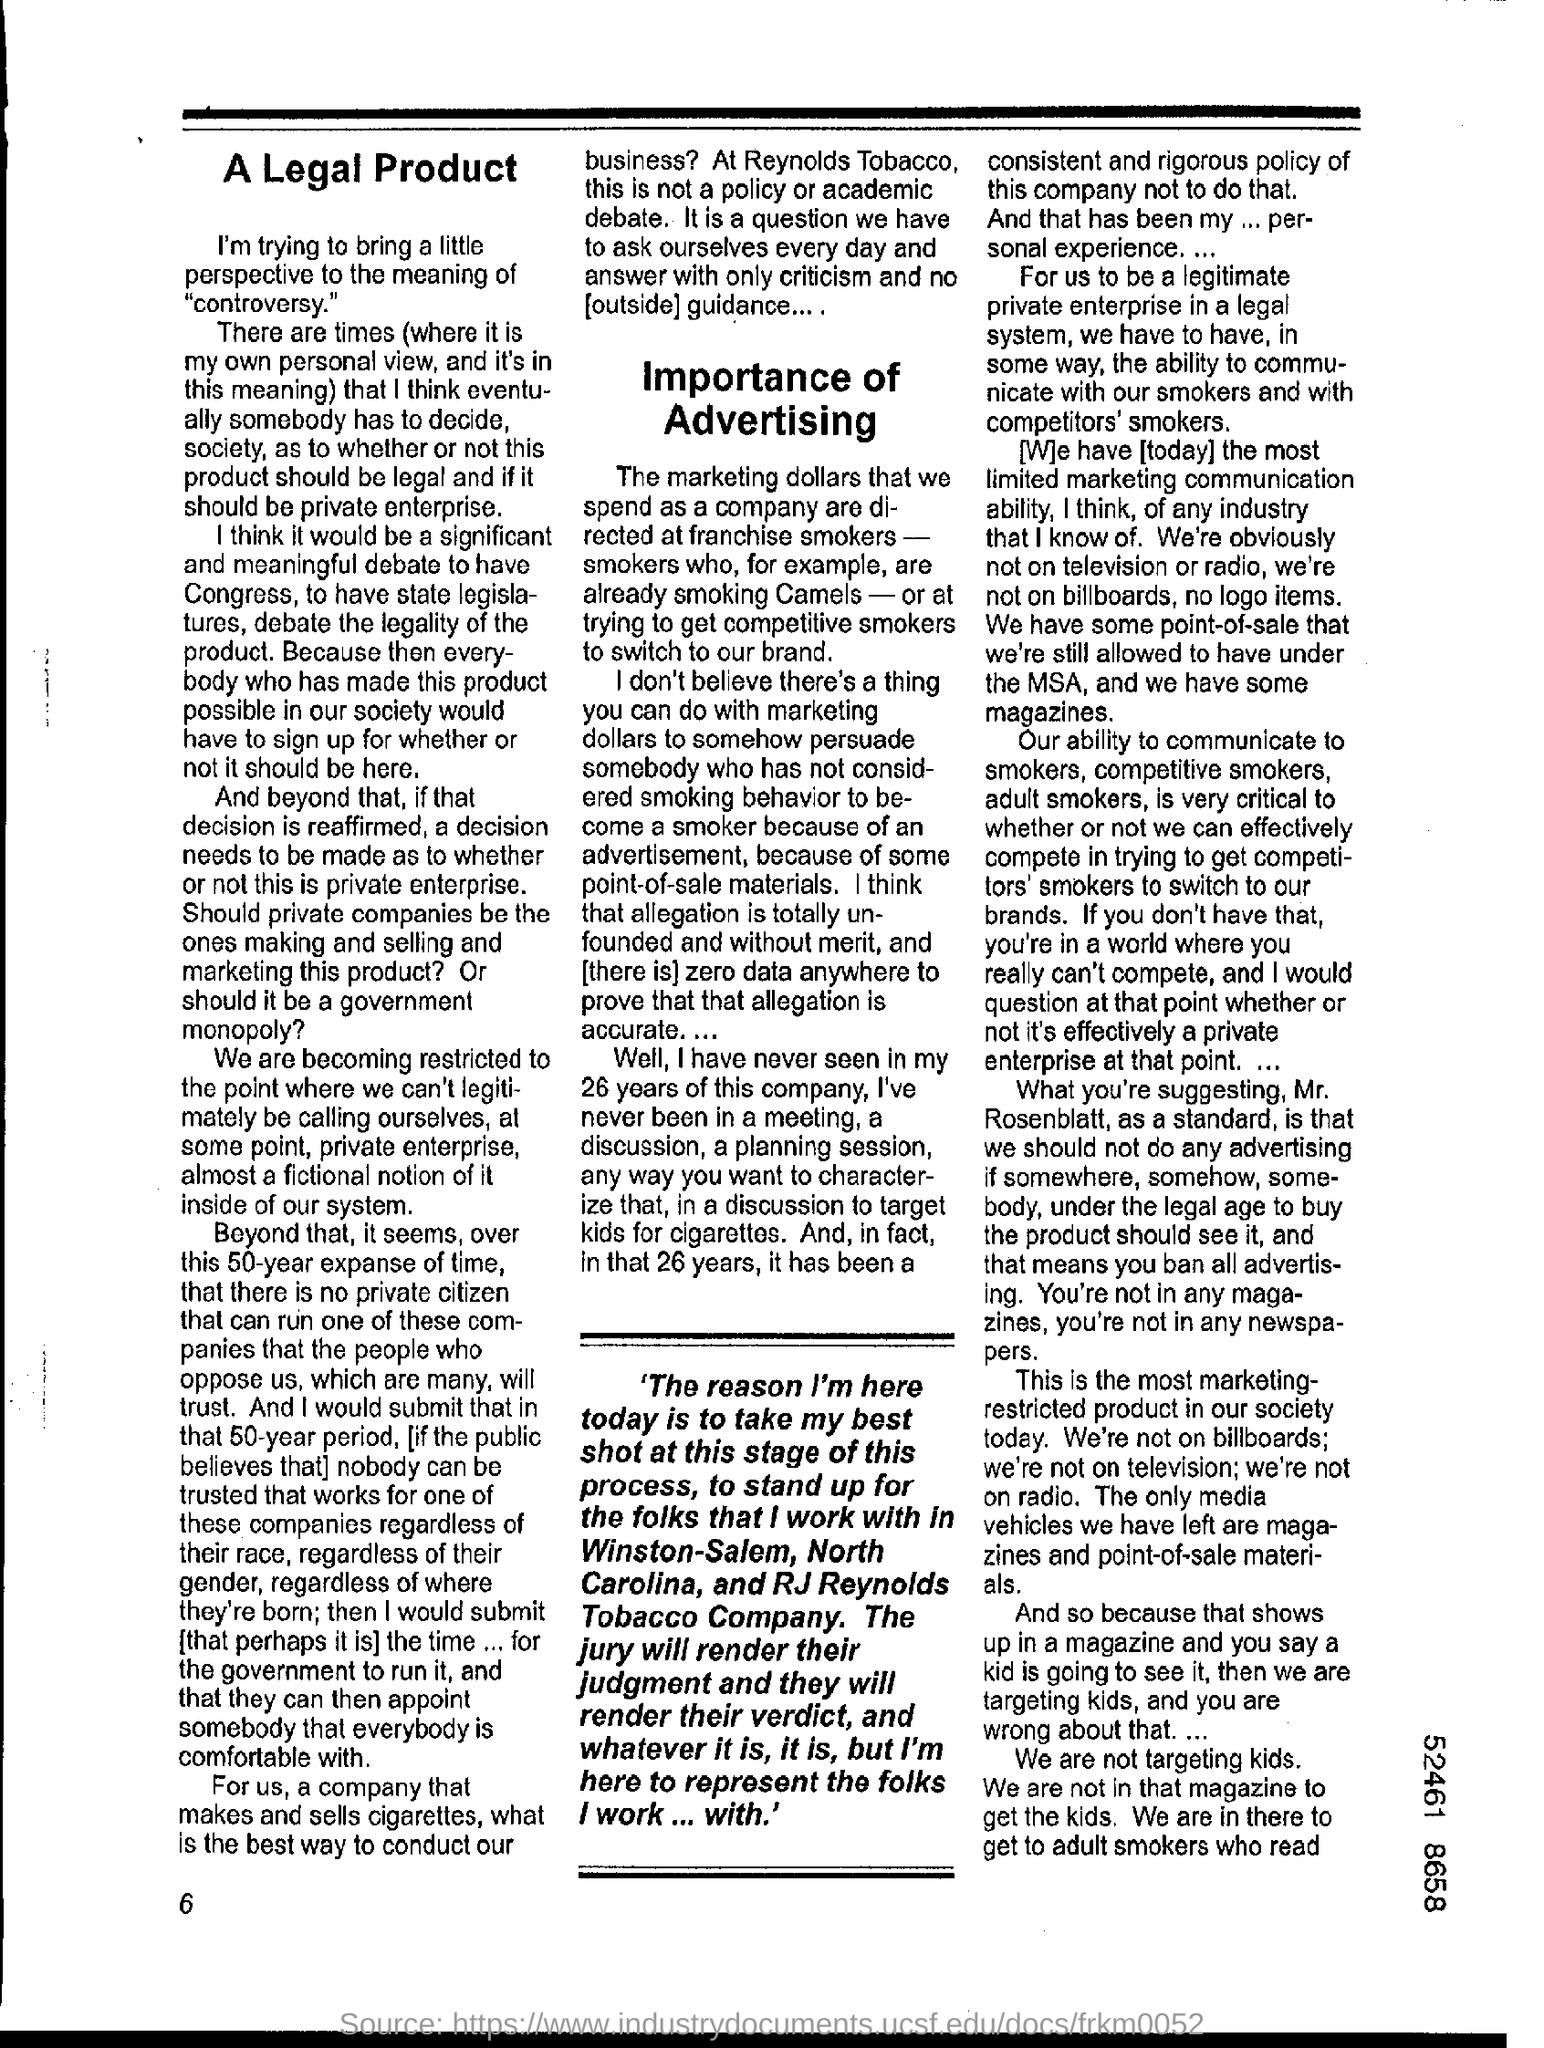Indicate a few pertinent items in this graphic. At the bottom left corner of the page is the number 6. 